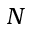<formula> <loc_0><loc_0><loc_500><loc_500>N</formula> 